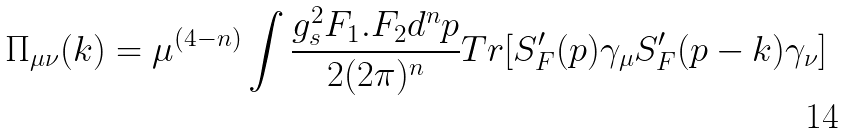<formula> <loc_0><loc_0><loc_500><loc_500>\Pi _ { \mu \nu } ( k ) = \mu ^ { ( 4 - n ) } \int \frac { g _ { s } ^ { 2 } F _ { 1 } . F _ { 2 } d ^ { n } p } { 2 ( 2 \pi ) ^ { n } } T r [ S _ { F } ^ { \prime } ( p ) \gamma _ { \mu } S _ { F } ^ { \prime } ( p - k ) \gamma _ { \nu } ]</formula> 